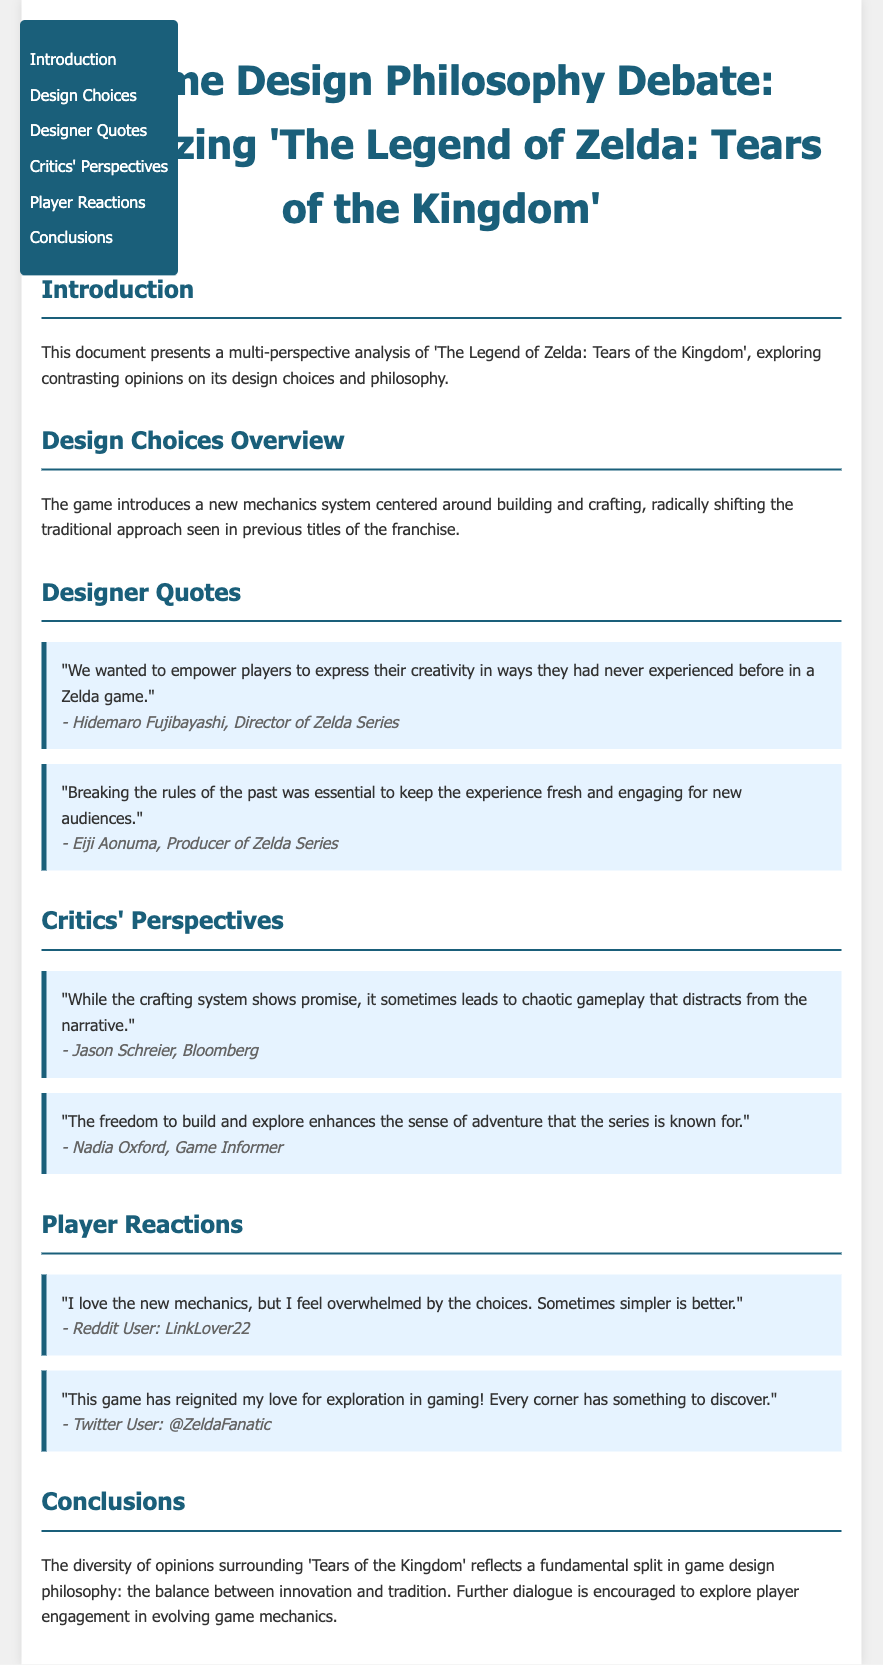What is the title of the document? The title is stated prominently at the top of the document.
Answer: Game Design Philosophy Debate: Analyzing 'The Legend of Zelda: Tears of the Kingdom' Who is the director of the Zelda Series? The name of the director is mentioned in the designer quotes section.
Answer: Hidemaro Fujibayashi What is one aspect of the new game design mentioned? The document outlines a new mechanics system that is highlighted in the design choices section.
Answer: Building and crafting Which critic noted the chaotic gameplay? The perspective mentioning chaotic gameplay can be found in the critics' perspectives section.
Answer: Jason Schreier How does Nadia Oxford view the new freedom in the game? The perspective from Nadia Oxford reflects her thoughts on the sense of adventure in the game.
Answer: Enhances the sense of adventure What player reaction indicates feeling overwhelmed? A specific player reaction expressing feeling overwhelmed by choices is included in the player reactions section.
Answer: "I love the new mechanics, but I feel overwhelmed by the choices." What is the primary theme of the conclusions section? The conclusions section summarizes the ongoing debate within game design philosophy.
Answer: Innovation and tradition Which social media platform did one player use to express their excitement? The player reaction includes the platform used for their comment.
Answer: Twitter 